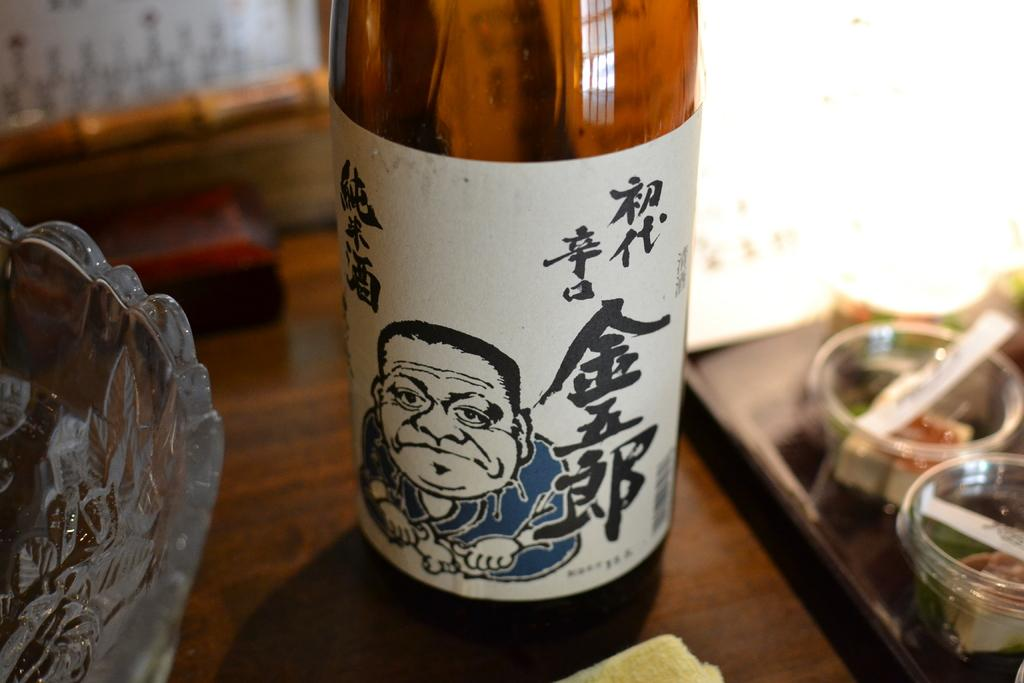What type of container is present in the image? There is a bottle in the image. What other type of container can be seen in the image? There is a flask in the image. What is the third container-like object in the image? There is a glass bowl in the image. Where are all these objects located? All the objects are on a table. Can you tell me where the toothbrush is placed on the table in the image? There is no toothbrush present in the image. How many parcels are visible on the table in the image? There are no parcels present in the image. 